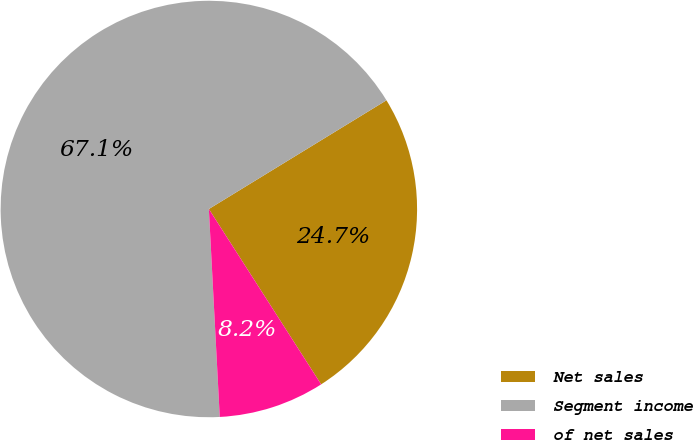<chart> <loc_0><loc_0><loc_500><loc_500><pie_chart><fcel>Net sales<fcel>Segment income<fcel>of net sales<nl><fcel>24.68%<fcel>67.09%<fcel>8.23%<nl></chart> 